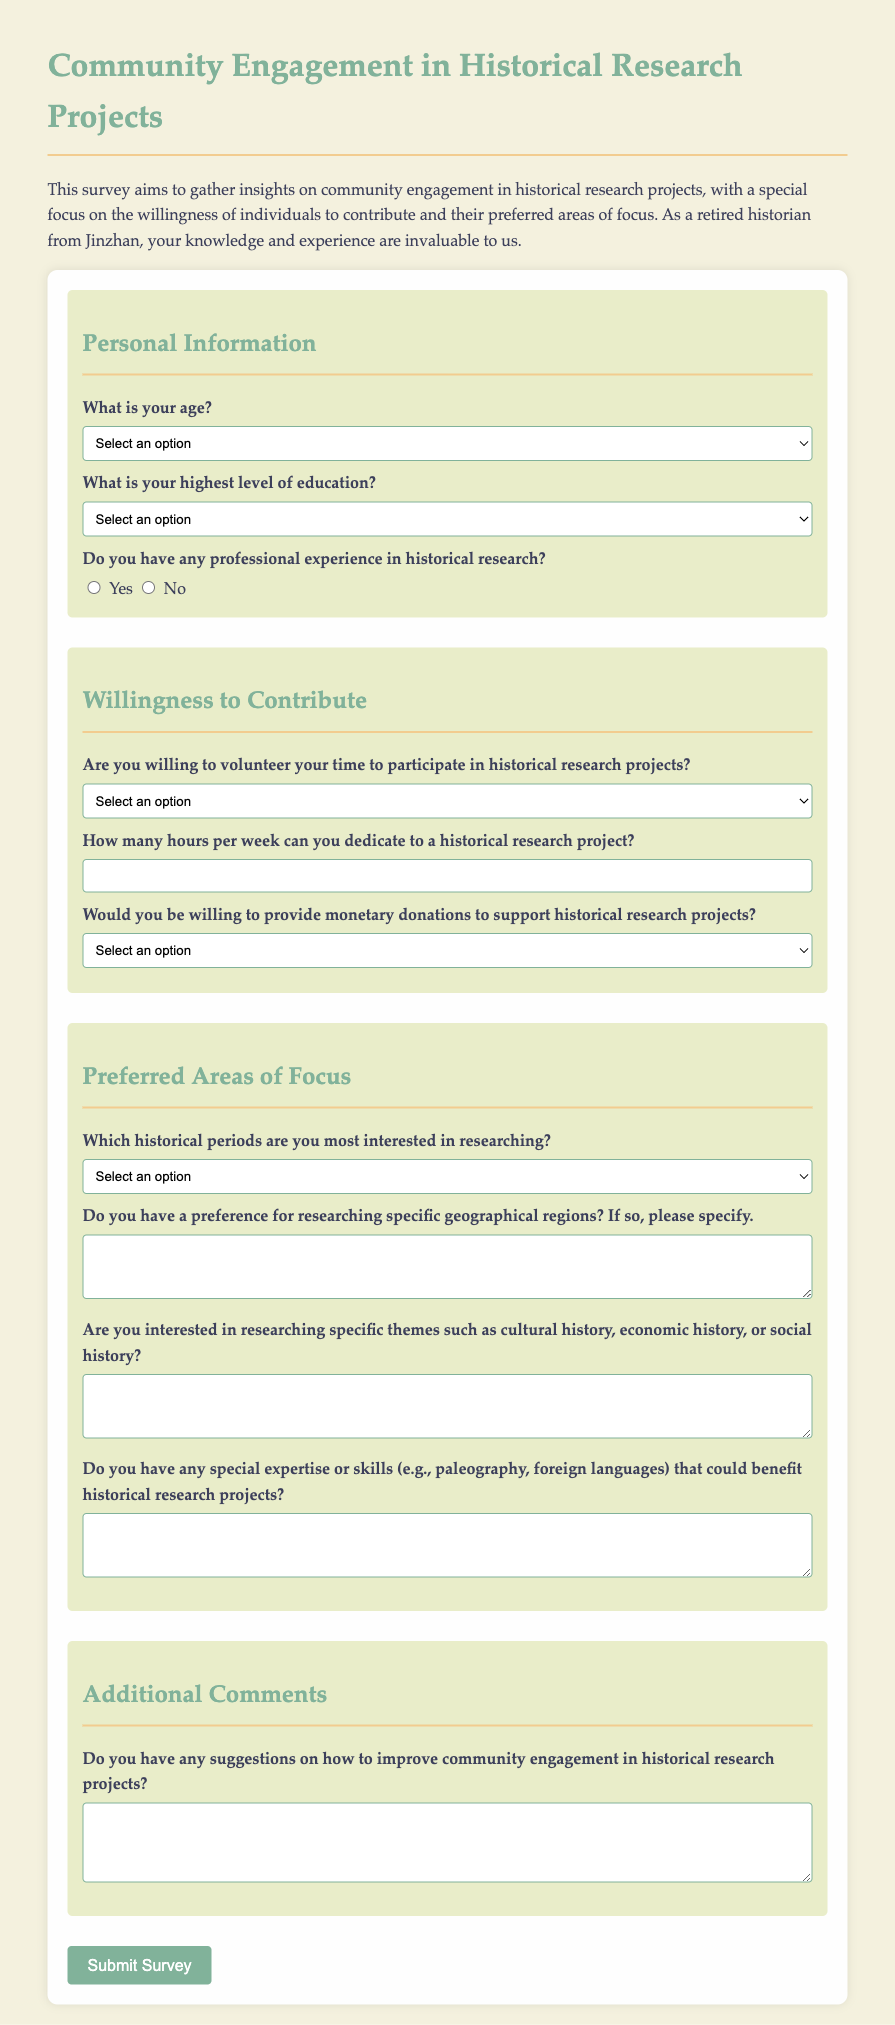What is the title of the survey? The title of the survey is explicitly stated at the top of the document.
Answer: Community Engagement in Historical Research Projects How many options are provided for the age selection? The number of options can be counted from the dropdown menu for age selection in the document.
Answer: 6 What is one of the educational qualifications listed? The educational qualifications can be extracted from the dropdown menu in the document.
Answer: Bachelor's Degree What is the minimum number of hours that can be dedicated to a historical research project? The minimum value is indicated as a requirement in the section about the number of hours per week for dedication.
Answer: 0 Which historical period can be selected for research? The specific options for historical periods can be found in the dropdown menu for preferred areas of focus.
Answer: Ancient History Is there an open-ended question about suggestions for improvement? Open-ended questions are identified in the form by checking for text areas that allow comments or suggestions.
Answer: Yes What is the primary purpose of the survey? The purpose is stated in the introductory paragraph of the document.
Answer: To gather insights on community engagement What type of questions are required regarding the willingness to volunteer? The nature of the questions regarding volunteering can be identified by examining the section related to willingness to contribute.
Answer: Select options from a dropdown menu What skills are requested in relation to benefiting historical research projects? Skills mentioned can be identified in the specific question about expertise related to historical research projects.
Answer: Paleography, foreign languages 